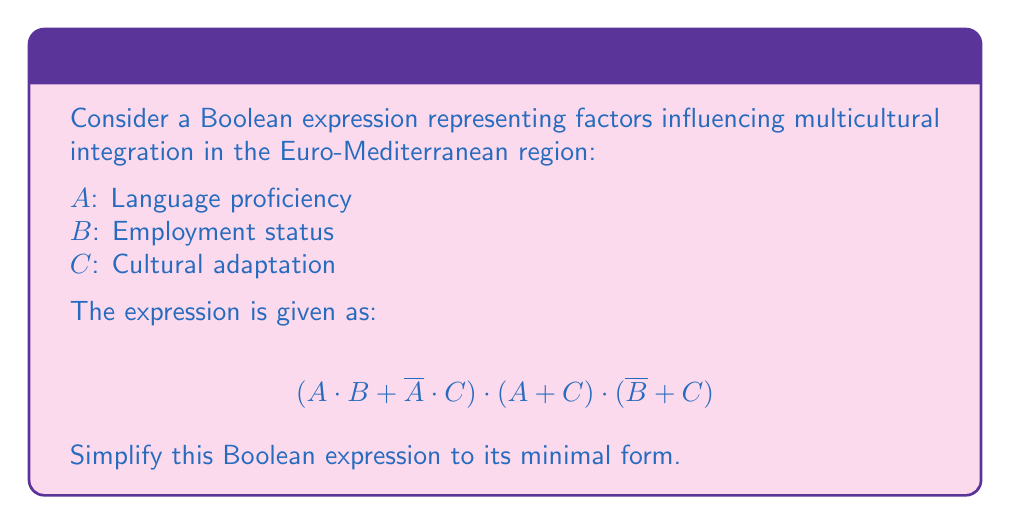Can you solve this math problem? Let's simplify this Boolean expression step by step:

1) First, let's distribute $(A + C)$ over $(A \cdot B + \overline{A} \cdot C)$:
   $$(A \cdot B + \overline{A} \cdot C) \cdot (A + C) \cdot (\overline{B} + C)$$
   $$= (A \cdot B \cdot A + A \cdot B \cdot C + \overline{A} \cdot C \cdot A + \overline{A} \cdot C \cdot C) \cdot (\overline{B} + C)$$

2) Simplify using Boolean algebra rules:
   - $A \cdot A = A$
   - $\overline{A} \cdot A = 0$
   - $C \cdot C = C$
   
   $$= (A \cdot B + A \cdot B \cdot C + 0 + \overline{A} \cdot C) \cdot (\overline{B} + C)$$
   $$= (A \cdot B + \overline{A} \cdot C) \cdot (\overline{B} + C)$$

3) Now distribute $(\overline{B} + C)$:
   $$= A \cdot B \cdot \overline{B} + A \cdot B \cdot C + \overline{A} \cdot C \cdot \overline{B} + \overline{A} \cdot C \cdot C$$

4) Simplify again:
   - $B \cdot \overline{B} = 0$
   - $C \cdot C = C$
   
   $$= 0 + A \cdot B \cdot C + \overline{A} \cdot C \cdot \overline{B} + \overline{A} \cdot C$$

5) Use the absorption law: $X + X \cdot Y = X$
   $$= A \cdot B \cdot C + \overline{A} \cdot C$$

6) This is the minimal form of the expression.
Answer: $A \cdot B \cdot C + \overline{A} \cdot C$ 